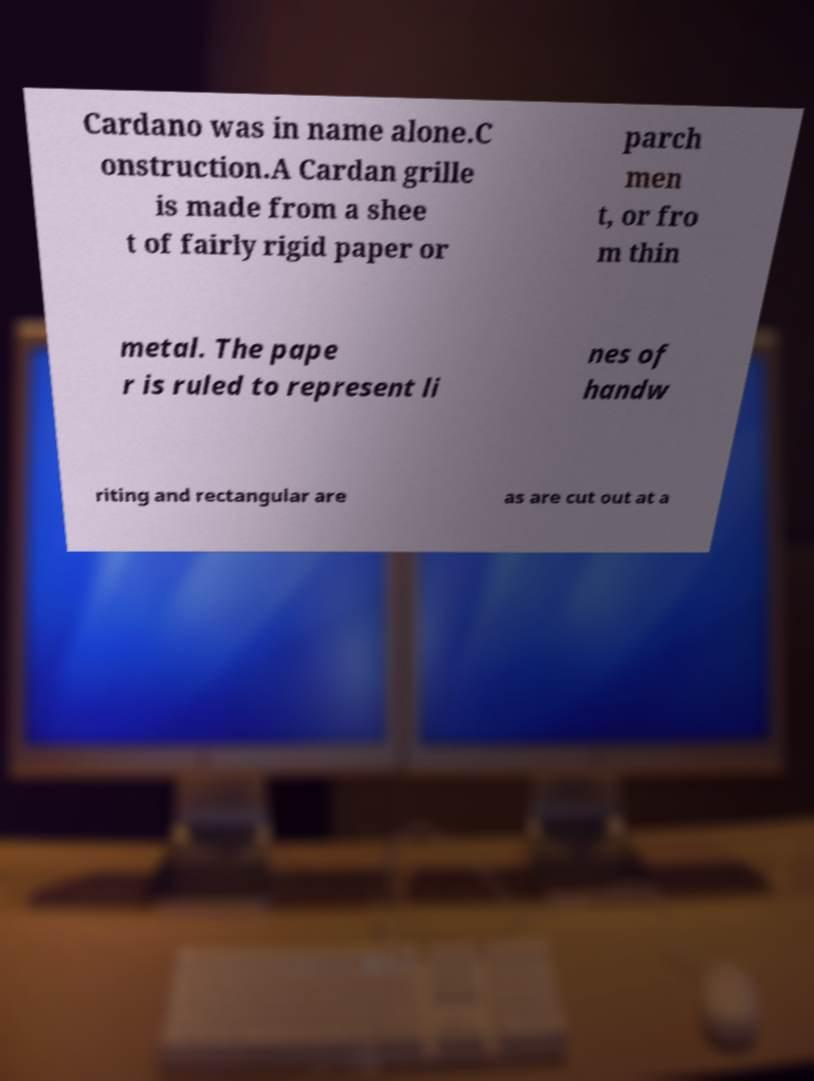Could you assist in decoding the text presented in this image and type it out clearly? Cardano was in name alone.C onstruction.A Cardan grille is made from a shee t of fairly rigid paper or parch men t, or fro m thin metal. The pape r is ruled to represent li nes of handw riting and rectangular are as are cut out at a 